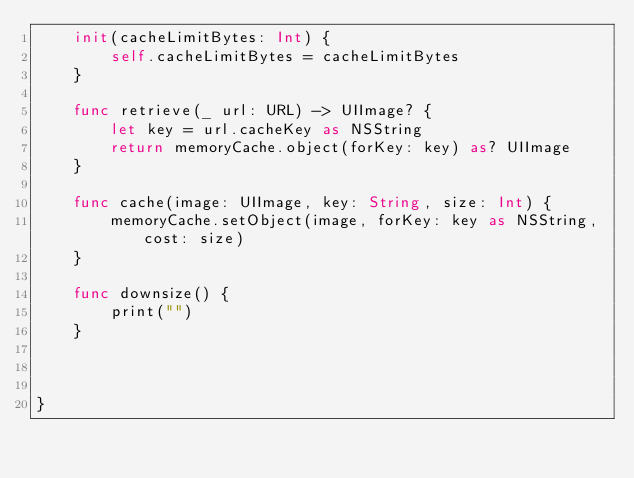<code> <loc_0><loc_0><loc_500><loc_500><_Swift_>    init(cacheLimitBytes: Int) {
        self.cacheLimitBytes = cacheLimitBytes
    }

    func retrieve(_ url: URL) -> UIImage? {
        let key = url.cacheKey as NSString
        return memoryCache.object(forKey: key) as? UIImage
    }
    
    func cache(image: UIImage, key: String, size: Int) {
        memoryCache.setObject(image, forKey: key as NSString, cost: size)
    }
    
    func downsize() {
        print("")
    }

    

}
</code> 